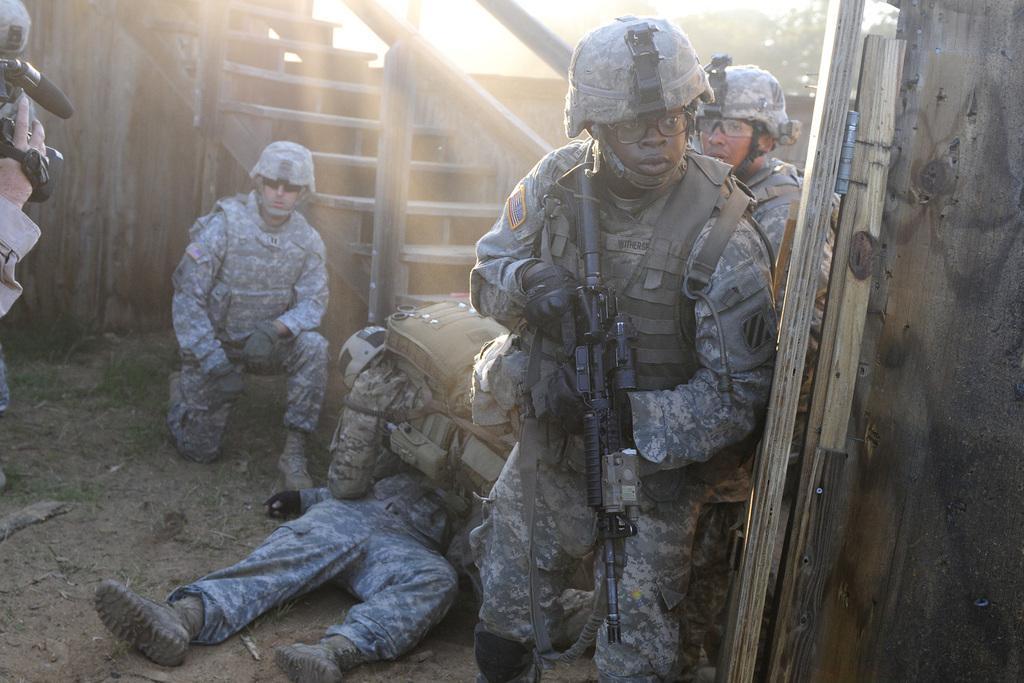Can you describe this image briefly? In this picture there are some military soldiers standing in the front with black gun. Behind there are some more soldiers standing and sitting on the ground. In the background there is a steps staircase with wooden railing. 